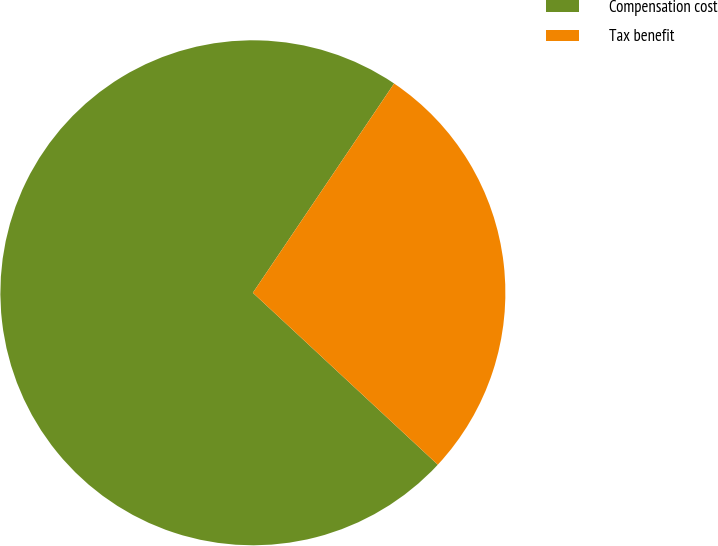Convert chart to OTSL. <chart><loc_0><loc_0><loc_500><loc_500><pie_chart><fcel>Compensation cost<fcel>Tax benefit<nl><fcel>72.53%<fcel>27.47%<nl></chart> 